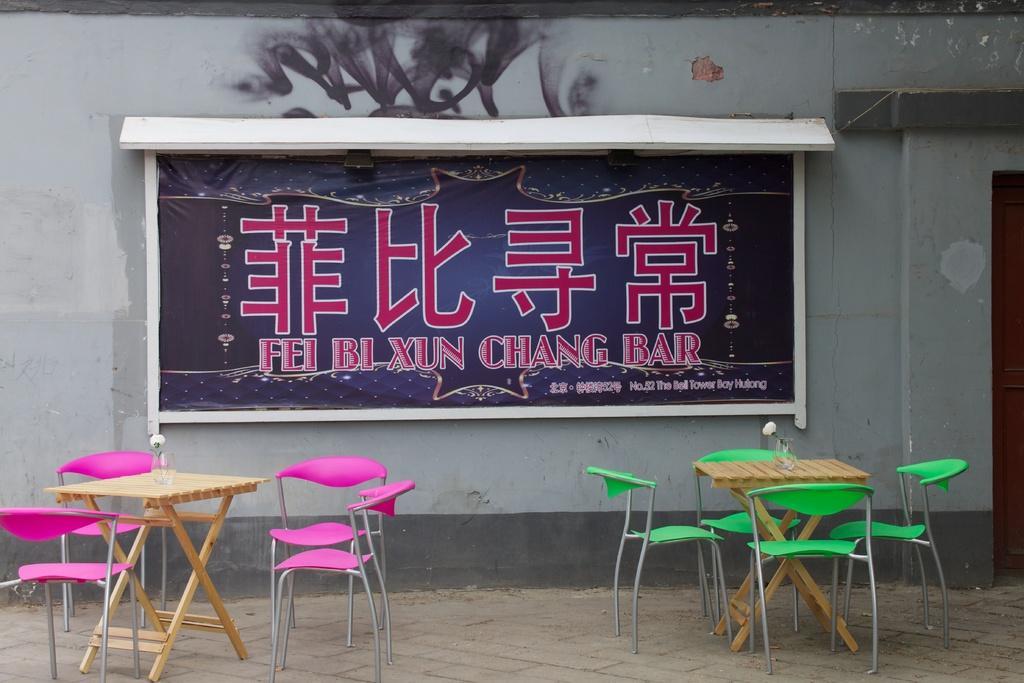Please provide a concise description of this image. Here I can see two tables and few chairs are placed on the ground. In the background there is a board attached to the wall. On the board, I can see some text. On the right side there is a door. 